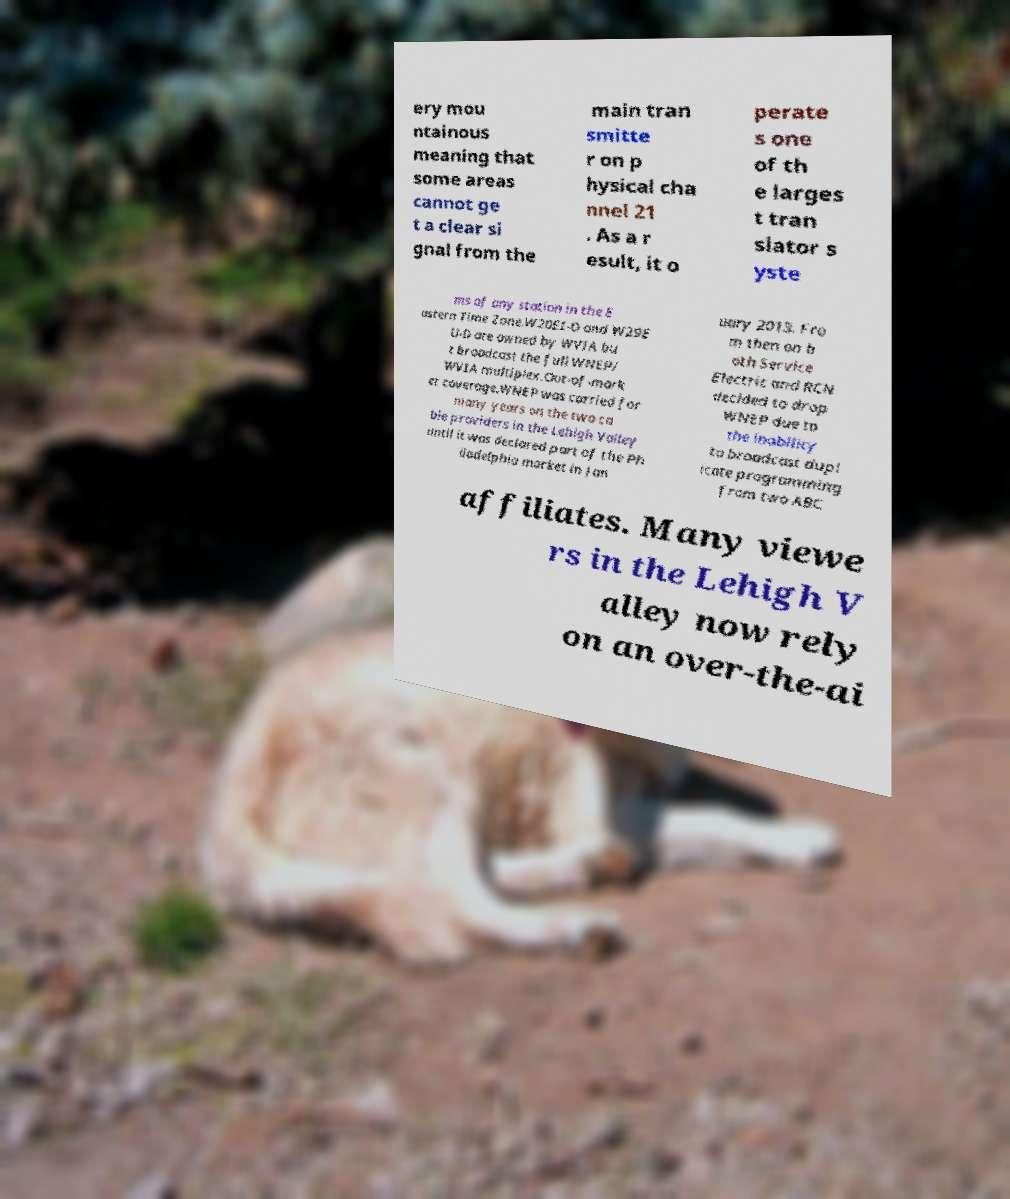Can you accurately transcribe the text from the provided image for me? ery mou ntainous meaning that some areas cannot ge t a clear si gnal from the main tran smitte r on p hysical cha nnel 21 . As a r esult, it o perate s one of th e larges t tran slator s yste ms of any station in the E astern Time Zone.W20EI-D and W29E U-D are owned by WVIA bu t broadcast the full WNEP/ WVIA multiplex.Out-of-mark et coverage.WNEP was carried for many years on the two ca ble providers in the Lehigh Valley until it was declared part of the Ph iladelphia market in Jan uary 2013. Fro m then on b oth Service Electric and RCN decided to drop WNEP due to the inability to broadcast dupl icate programming from two ABC affiliates. Many viewe rs in the Lehigh V alley now rely on an over-the-ai 